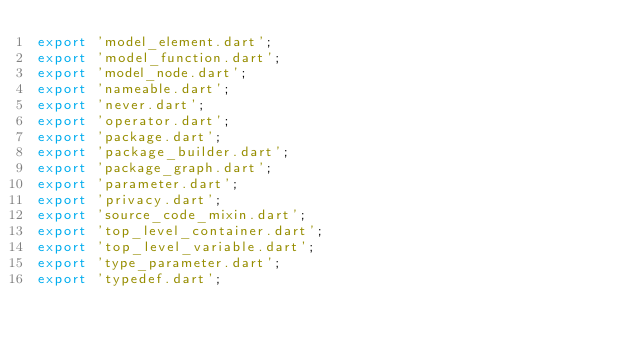<code> <loc_0><loc_0><loc_500><loc_500><_Dart_>export 'model_element.dart';
export 'model_function.dart';
export 'model_node.dart';
export 'nameable.dart';
export 'never.dart';
export 'operator.dart';
export 'package.dart';
export 'package_builder.dart';
export 'package_graph.dart';
export 'parameter.dart';
export 'privacy.dart';
export 'source_code_mixin.dart';
export 'top_level_container.dart';
export 'top_level_variable.dart';
export 'type_parameter.dart';
export 'typedef.dart';
</code> 